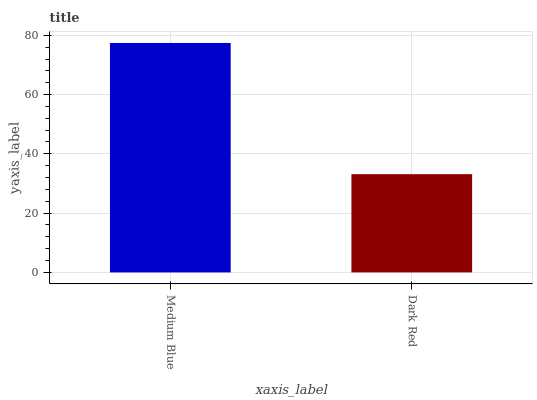Is Dark Red the minimum?
Answer yes or no. Yes. Is Medium Blue the maximum?
Answer yes or no. Yes. Is Dark Red the maximum?
Answer yes or no. No. Is Medium Blue greater than Dark Red?
Answer yes or no. Yes. Is Dark Red less than Medium Blue?
Answer yes or no. Yes. Is Dark Red greater than Medium Blue?
Answer yes or no. No. Is Medium Blue less than Dark Red?
Answer yes or no. No. Is Medium Blue the high median?
Answer yes or no. Yes. Is Dark Red the low median?
Answer yes or no. Yes. Is Dark Red the high median?
Answer yes or no. No. Is Medium Blue the low median?
Answer yes or no. No. 